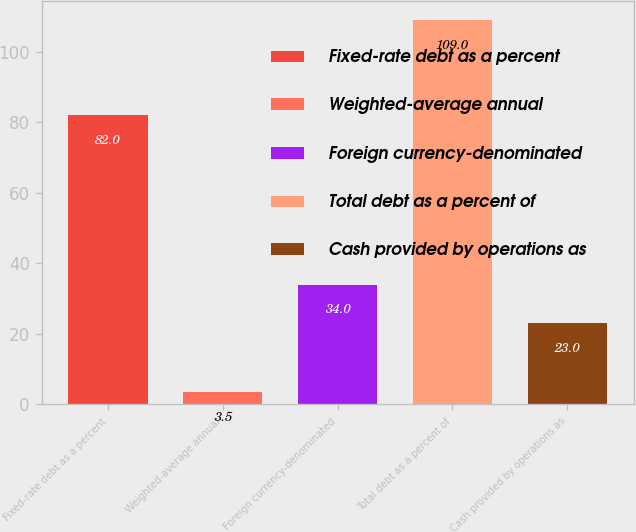Convert chart to OTSL. <chart><loc_0><loc_0><loc_500><loc_500><bar_chart><fcel>Fixed-rate debt as a percent<fcel>Weighted-average annual<fcel>Foreign currency-denominated<fcel>Total debt as a percent of<fcel>Cash provided by operations as<nl><fcel>82<fcel>3.5<fcel>34<fcel>109<fcel>23<nl></chart> 